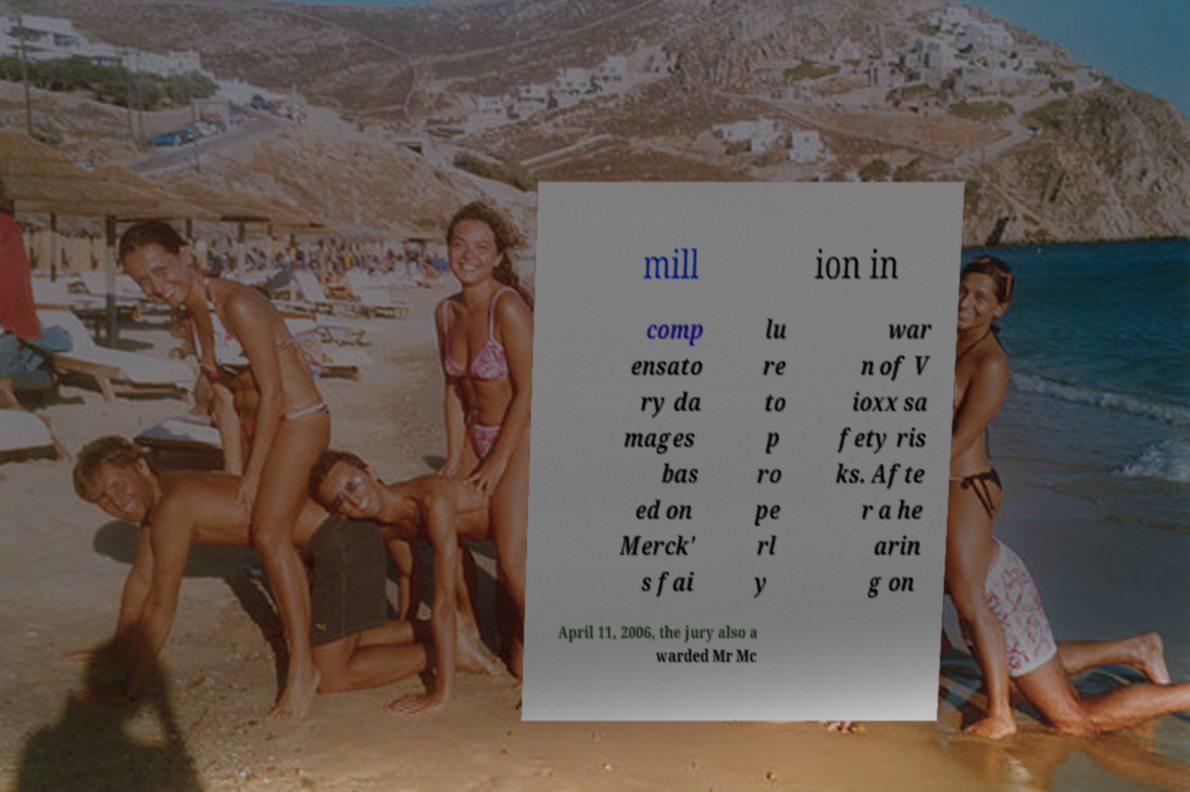Could you assist in decoding the text presented in this image and type it out clearly? mill ion in comp ensato ry da mages bas ed on Merck' s fai lu re to p ro pe rl y war n of V ioxx sa fety ris ks. Afte r a he arin g on April 11, 2006, the jury also a warded Mr Mc 